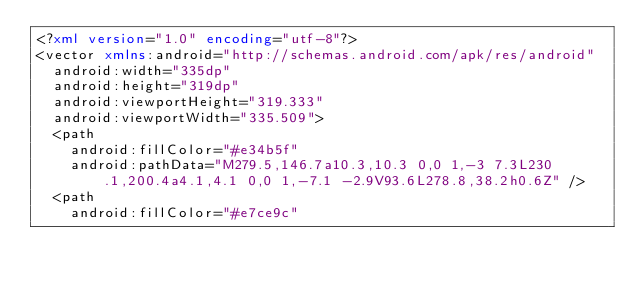Convert code to text. <code><loc_0><loc_0><loc_500><loc_500><_XML_><?xml version="1.0" encoding="utf-8"?>
<vector xmlns:android="http://schemas.android.com/apk/res/android"
  android:width="335dp"
  android:height="319dp"
  android:viewportHeight="319.333"
  android:viewportWidth="335.509">
  <path
    android:fillColor="#e34b5f"
    android:pathData="M279.5,146.7a10.3,10.3 0,0 1,-3 7.3L230.1,200.4a4.1,4.1 0,0 1,-7.1 -2.9V93.6L278.8,38.2h0.6Z" />
  <path
    android:fillColor="#e7ce9c"</code> 